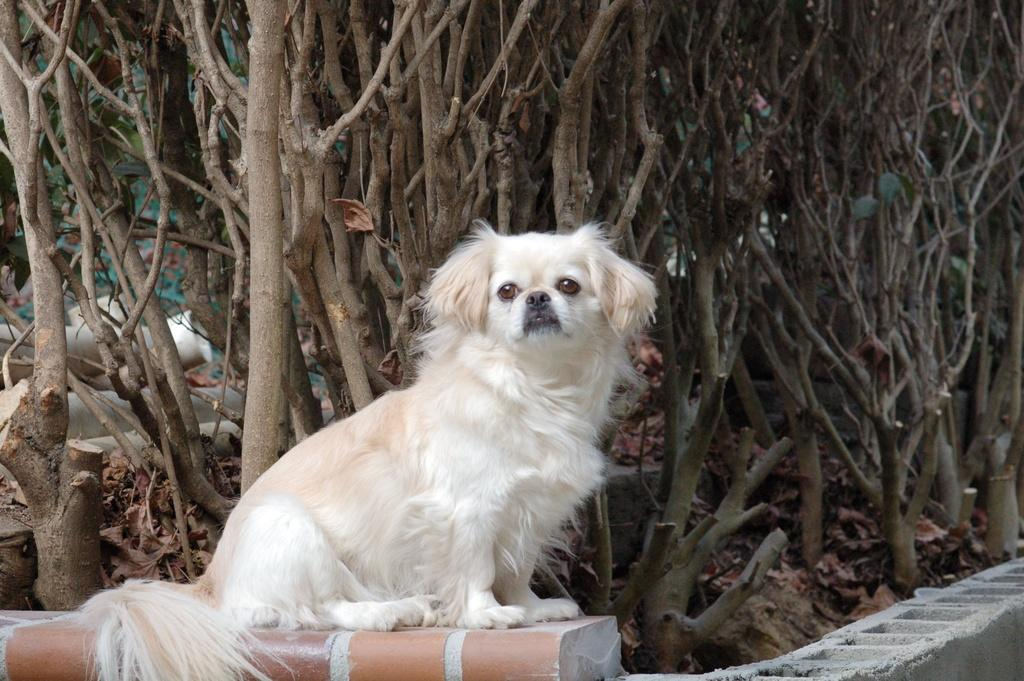What type of animal can be seen in the image? There is a dog in the image. What kind of structure is present in the image? There is a concrete structure in the image. What can be seen in the background of the image? Trees and dried leaves are visible in the background of the image. What type of hen is part of the team in the image? There is no hen or team present in the image. What kind of system is responsible for the dried leaves in the image? There is no system responsible for the dried leaves in the image; they are a natural occurrence. 